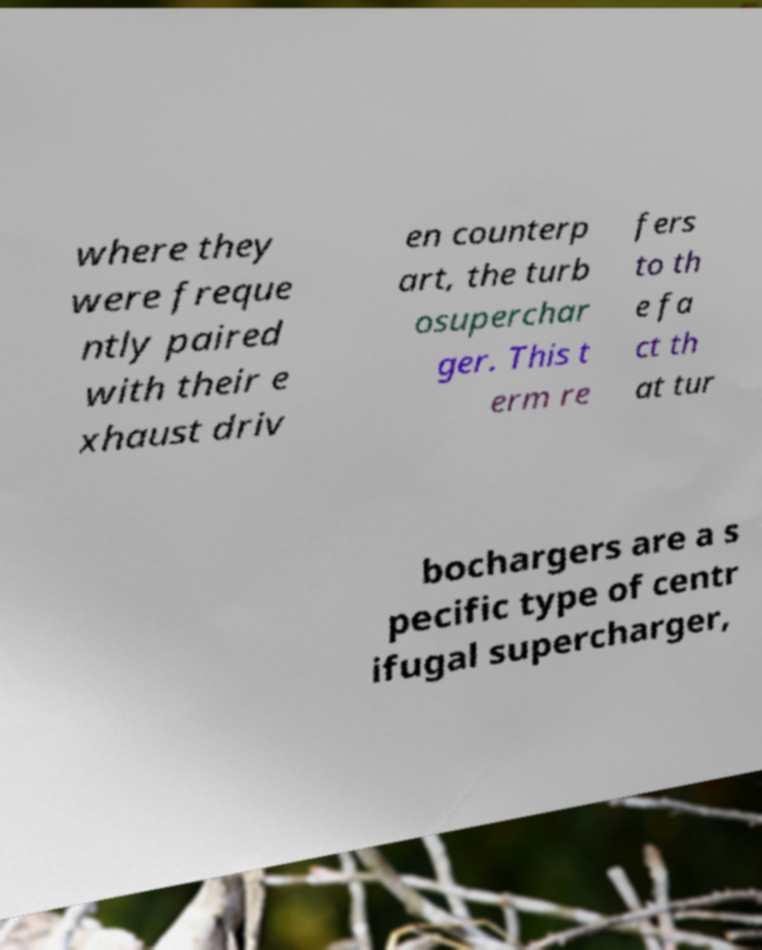For documentation purposes, I need the text within this image transcribed. Could you provide that? where they were freque ntly paired with their e xhaust driv en counterp art, the turb osuperchar ger. This t erm re fers to th e fa ct th at tur bochargers are a s pecific type of centr ifugal supercharger, 